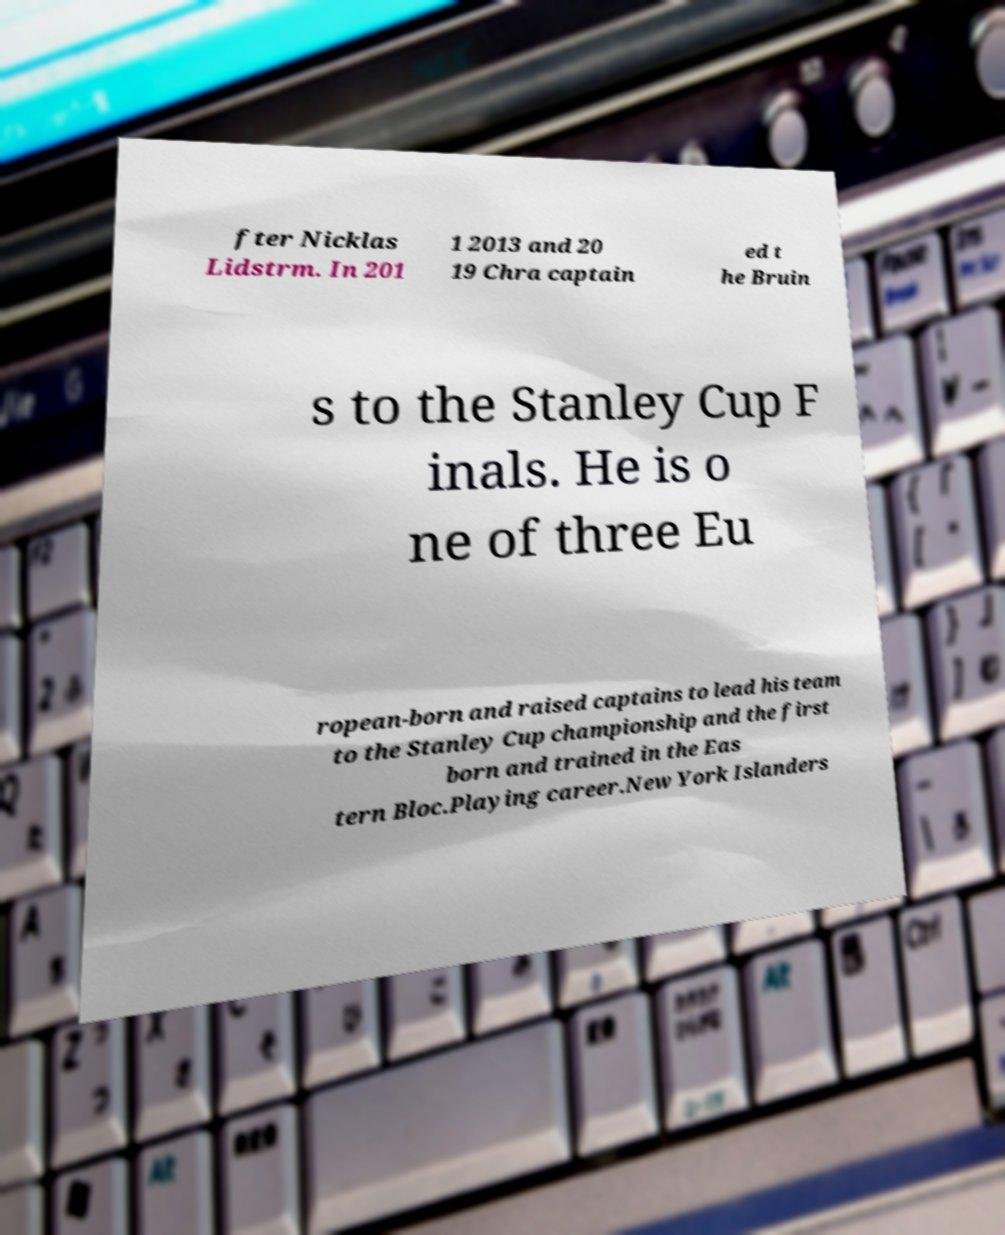For documentation purposes, I need the text within this image transcribed. Could you provide that? fter Nicklas Lidstrm. In 201 1 2013 and 20 19 Chra captain ed t he Bruin s to the Stanley Cup F inals. He is o ne of three Eu ropean-born and raised captains to lead his team to the Stanley Cup championship and the first born and trained in the Eas tern Bloc.Playing career.New York Islanders 